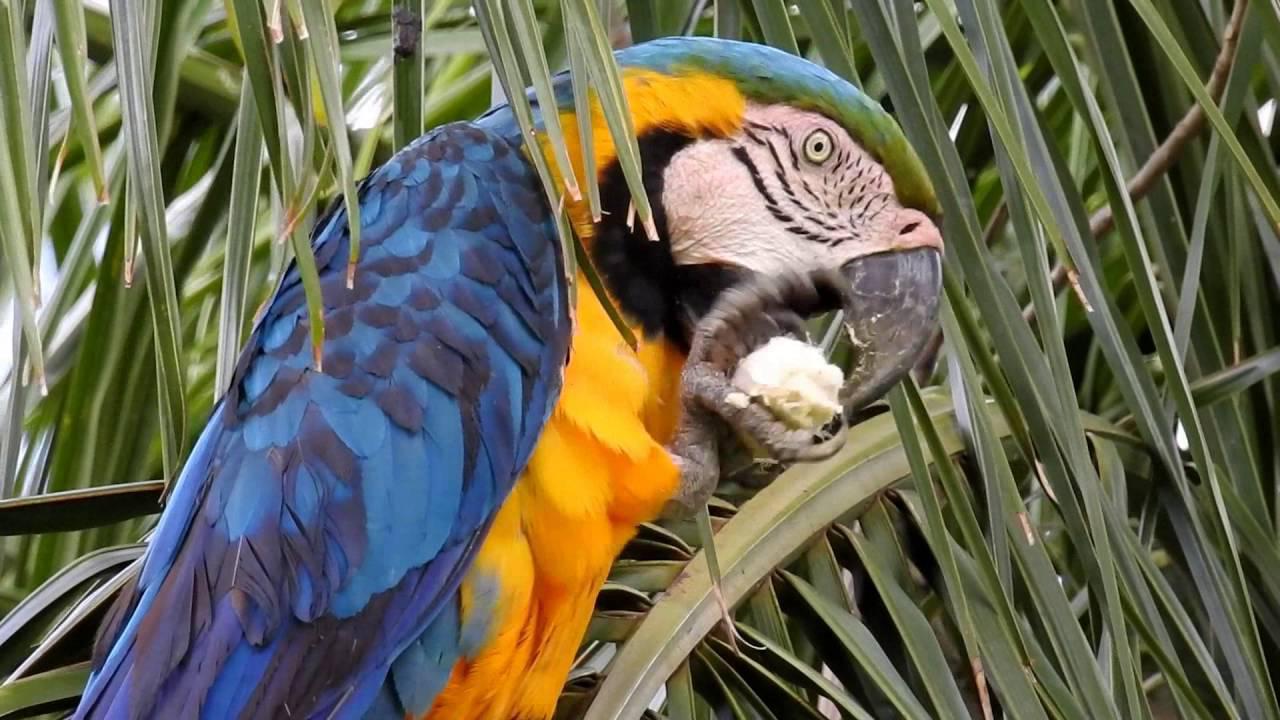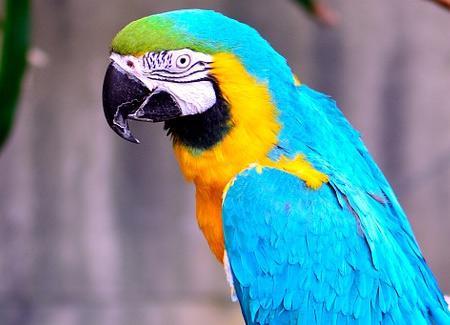The first image is the image on the left, the second image is the image on the right. For the images shown, is this caption "There are at least two blue parrots in the right image." true? Answer yes or no. No. The first image is the image on the left, the second image is the image on the right. Evaluate the accuracy of this statement regarding the images: "An image contains one red-headed parrot facing rightward, and the other image contains blue-headed birds.". Is it true? Answer yes or no. No. 